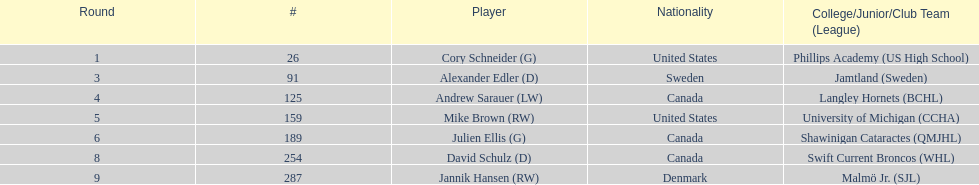Who was the inaugural player to be selected in the draft? Cory Schneider (G). 